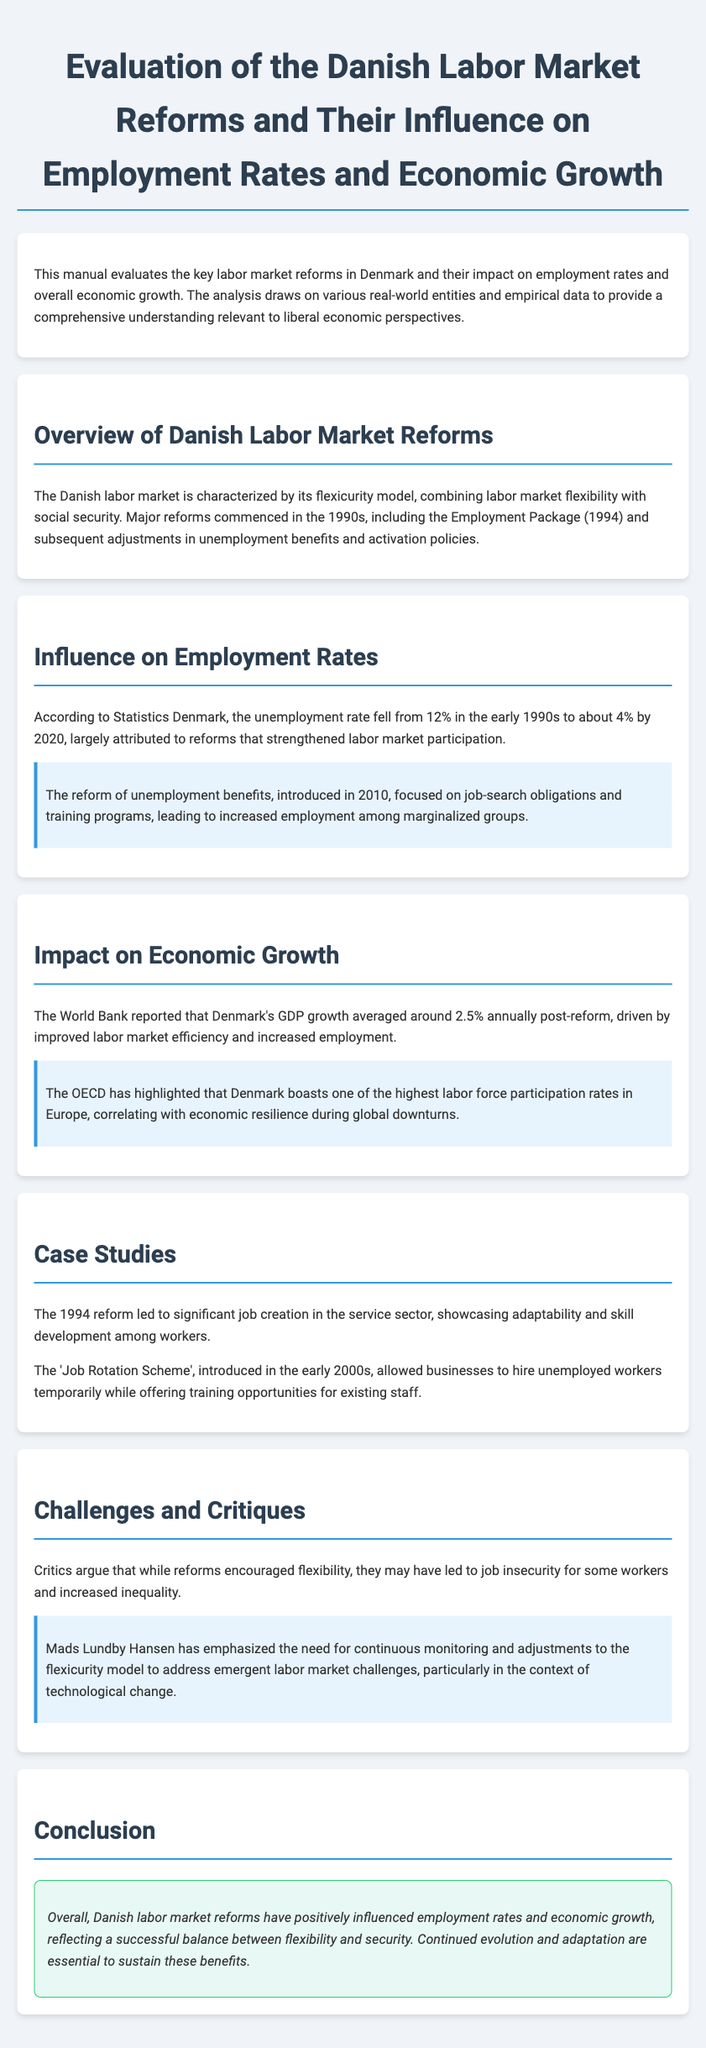What is the primary focus of the manual? The primary focus of the manual is the evaluation of Danish labor market reforms and their influence on employment rates and economic growth.
Answer: evaluation of Danish labor market reforms What was the unemployment rate in Denmark in the early 1990s? The document states that the unemployment rate fell from 12% in the early 1990s to about 4% by 2020, indicating that it was 12% at that time.
Answer: 12% What year did the reform of unemployment benefits take place? The reform of unemployment benefits was introduced in 2010, as detailed in the section about influence on employment rates.
Answer: 2010 What is Denmark's average GDP growth post-reform according to the World Bank? The World Bank reported that Denmark's GDP growth averaged around 2.5% annually post-reform, addressing the economic growth impact.
Answer: 2.5% Which sector significantly benefited from the 1994 reform? The 1994 reform led to significant job creation in the service sector, as mentioned in the case studies section of the document.
Answer: service sector What is the overall conclusion of the manual pertaining to labor market reforms? The manual concludes that Danish labor market reforms have positively influenced employment rates and economic growth.
Answer: positively influenced employment rates and economic growth What model combines labor market flexibility with social security in Denmark? The document describes the Danish labor market as characterized by its flexicurity model.
Answer: flexicurity model Who emphasized the need for continuous monitoring of the flexicurity model? The document mentions that Mads Lundby Hansen emphasized the need for continuous monitoring and adjustments to the flexicurity model.
Answer: Mads Lundby Hansen 